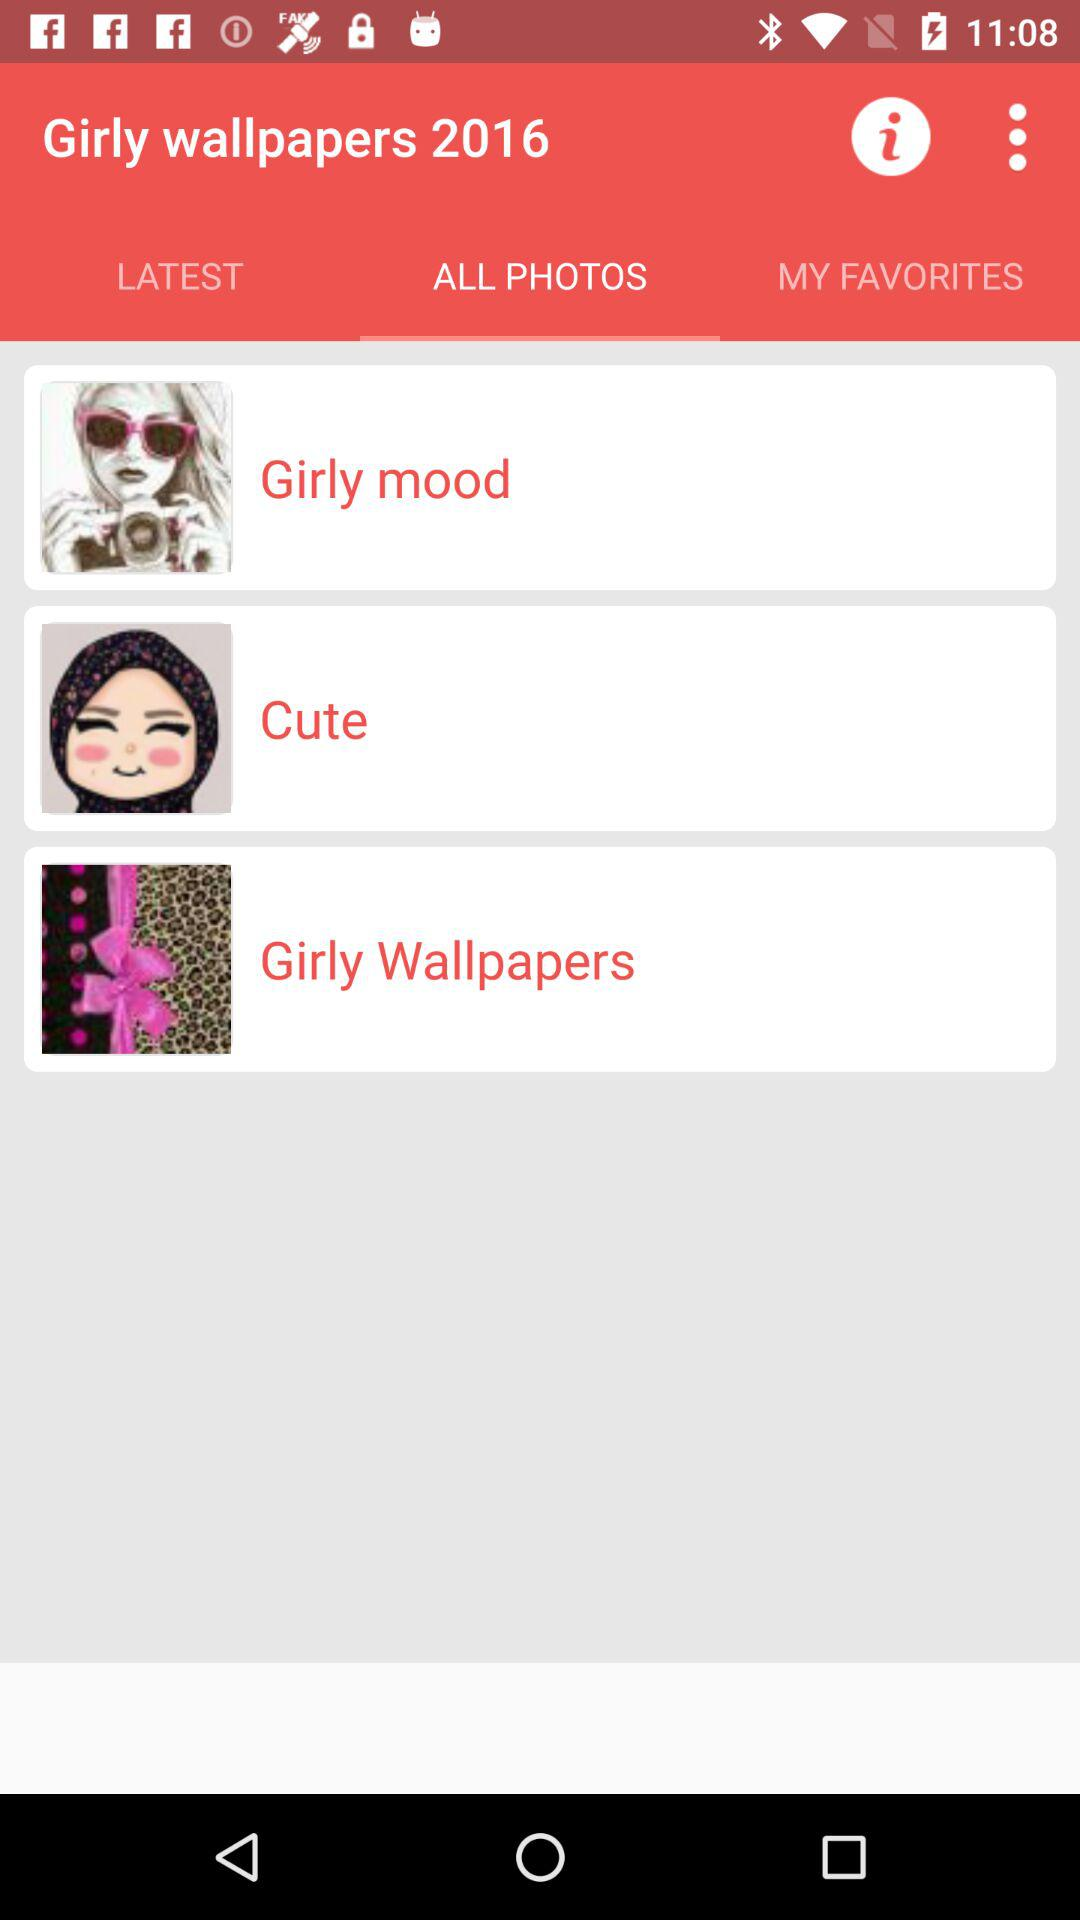What is the application name? The application name is "Girly wallpapers 2016". 